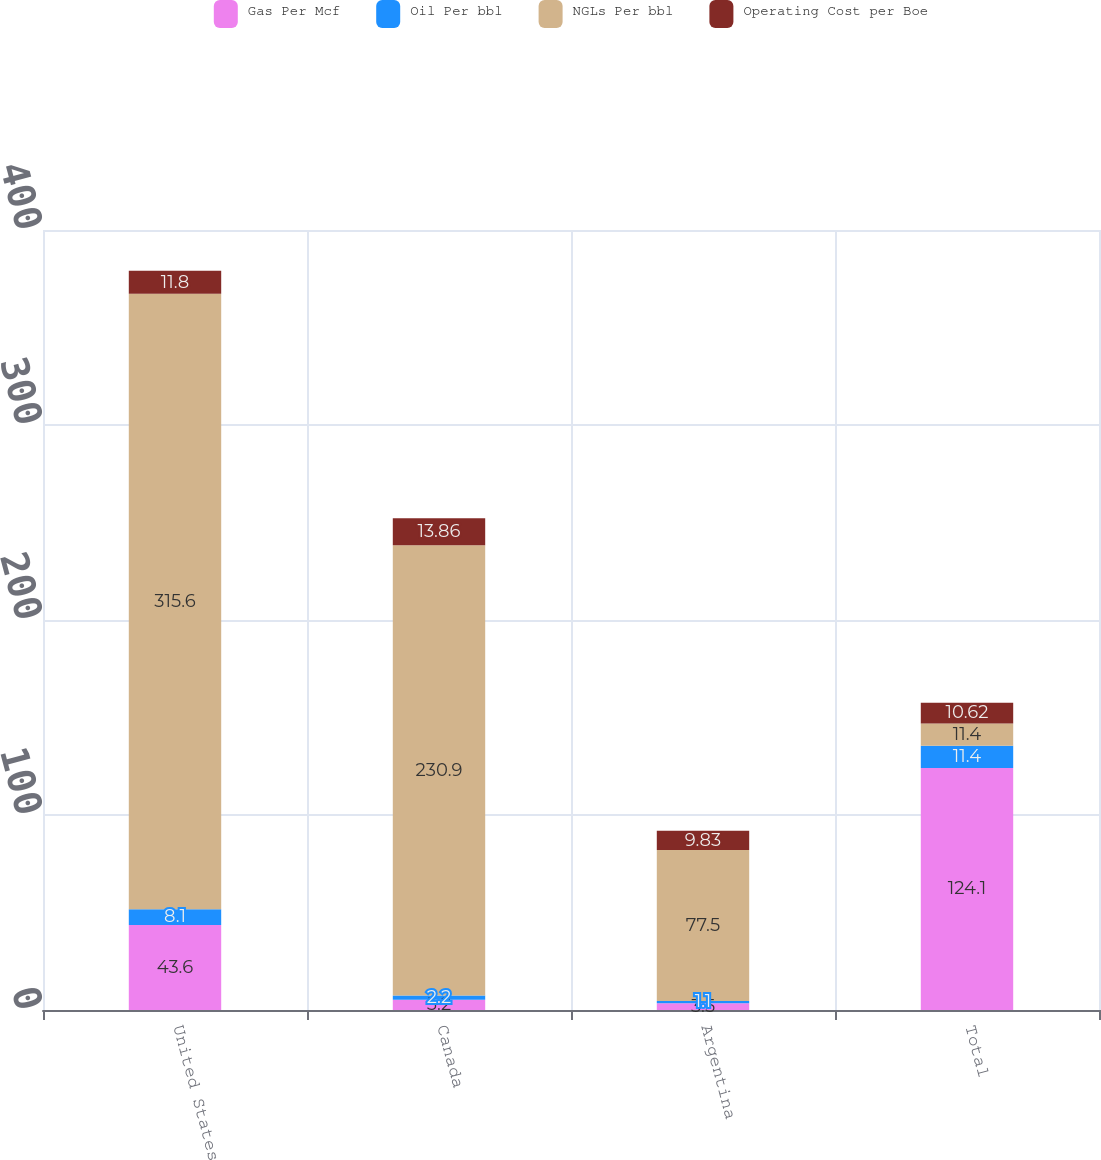Convert chart. <chart><loc_0><loc_0><loc_500><loc_500><stacked_bar_chart><ecel><fcel>United States<fcel>Canada<fcel>Argentina<fcel>Total<nl><fcel>Gas Per Mcf<fcel>43.6<fcel>5.2<fcel>3.5<fcel>124.1<nl><fcel>Oil Per bbl<fcel>8.1<fcel>2.2<fcel>1.1<fcel>11.4<nl><fcel>NGLs Per bbl<fcel>315.6<fcel>230.9<fcel>77.5<fcel>11.4<nl><fcel>Operating Cost per Boe<fcel>11.8<fcel>13.86<fcel>9.83<fcel>10.62<nl></chart> 